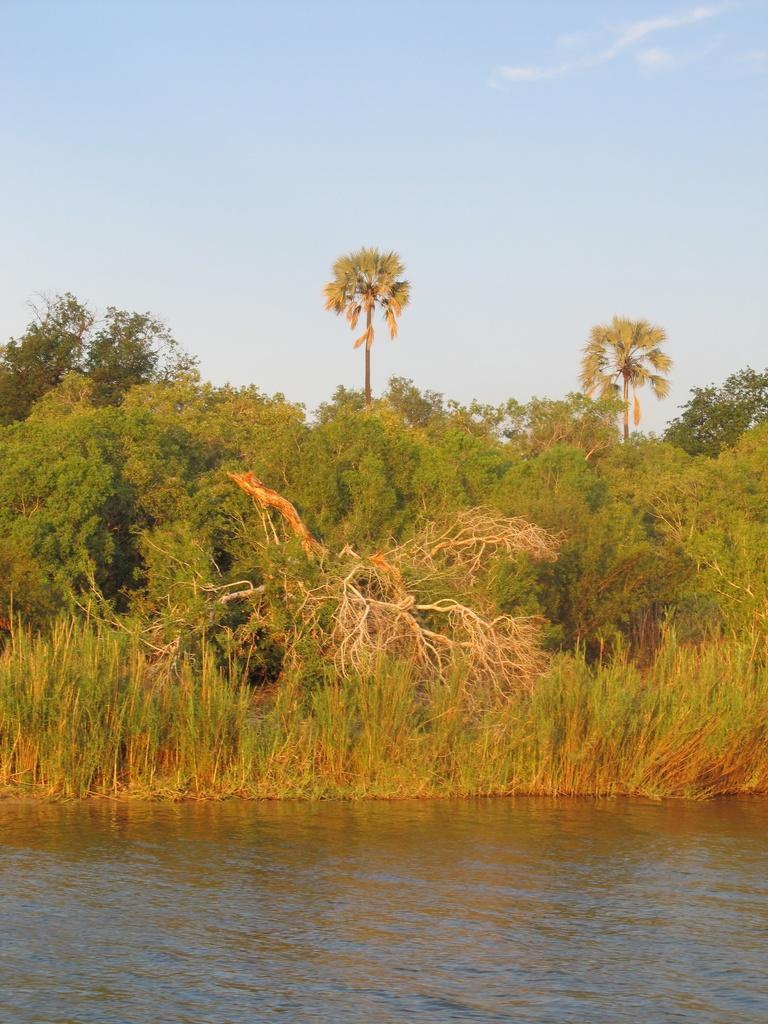What is the primary element visible in the image? There is water in the image. What type of vegetation can be seen in the image? There are plants and trees in the image. What note is dad playing on the side in the image? There is no person or musical instrument present in the image, so it is not possible to determine if someone is playing a note or if there is a dad in the image. 